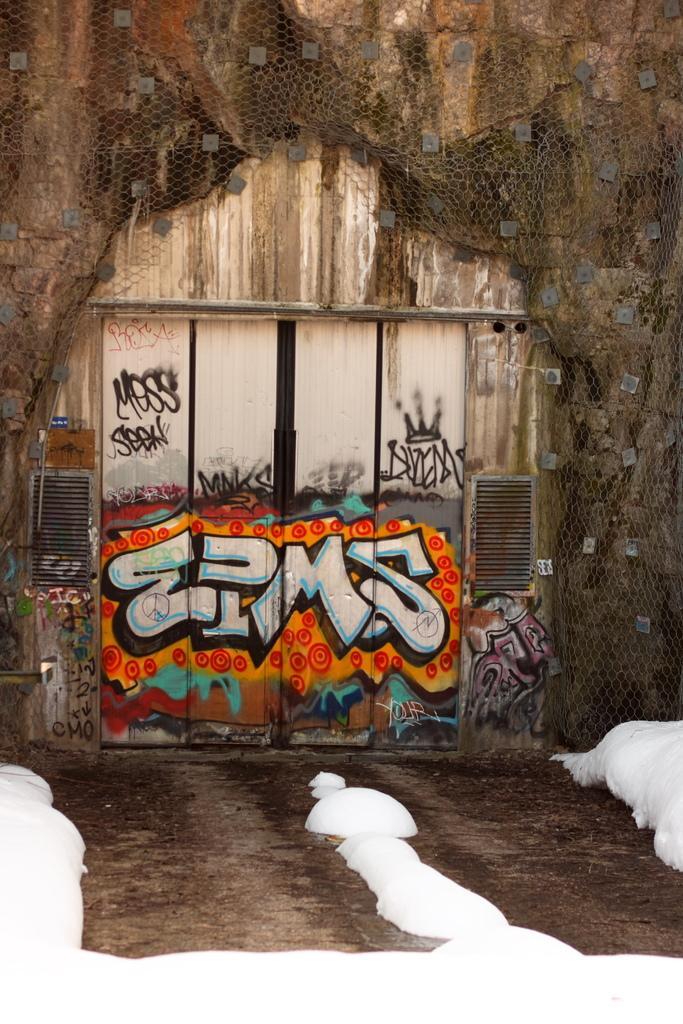Describe this image in one or two sentences. In this image there is a wooden building with door in the middle where we can see some graffiti, also there is a net on the wall of building. 